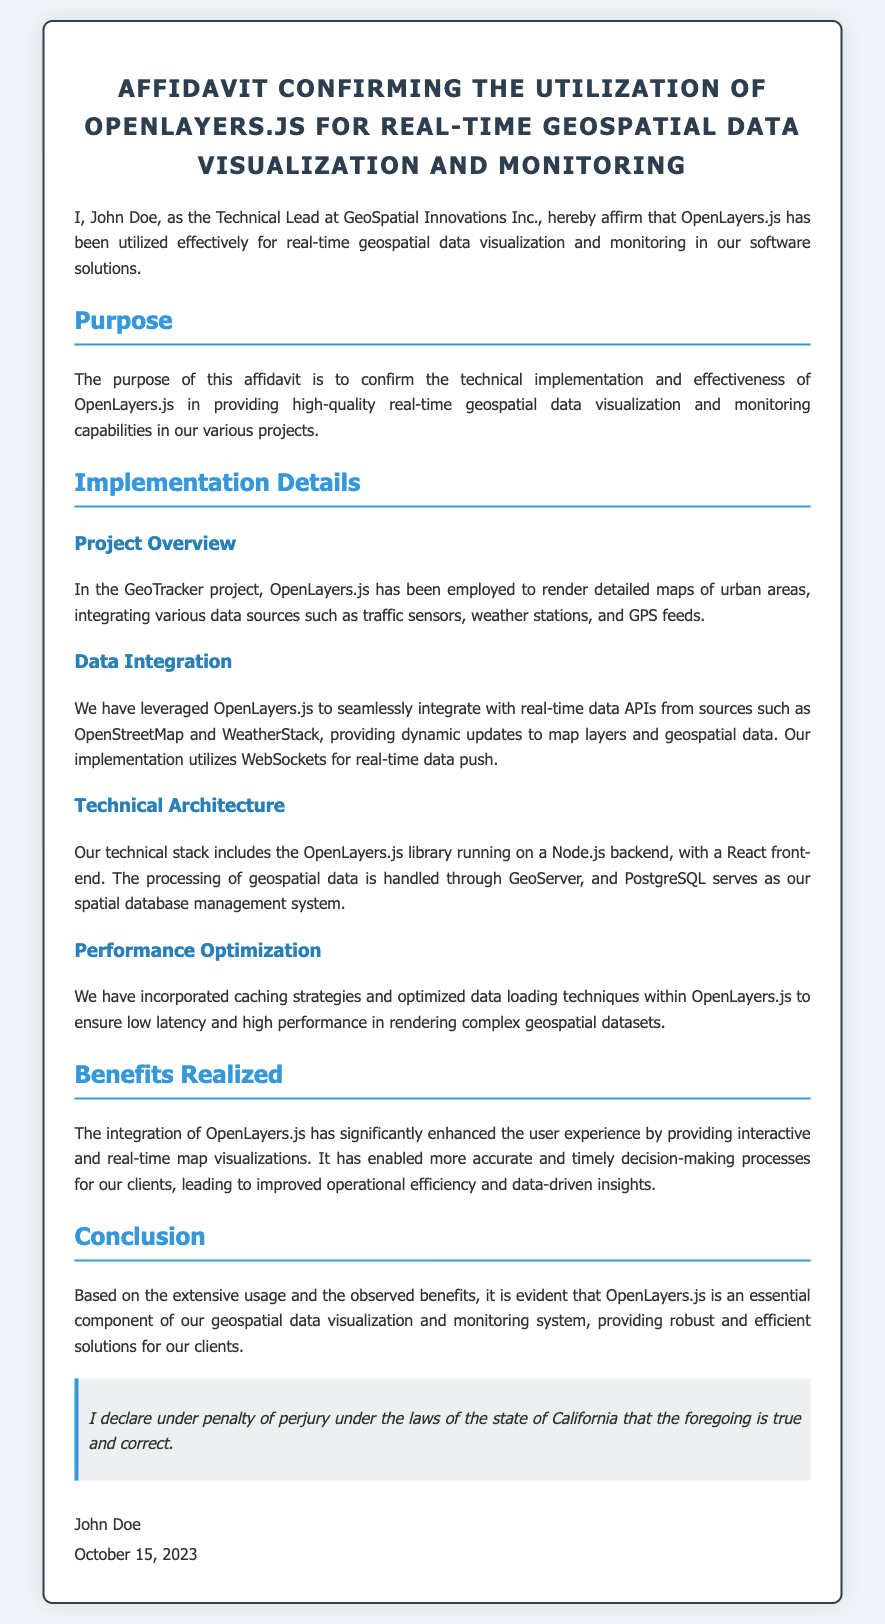What is the name of the Technical Lead? The Technical Lead's name is mentioned at the beginning of the affidavit, confirming their identity and role.
Answer: John Doe What is the date of the affidavit? The date at the end of the affidavit indicates when the declaration was made by the Technical Lead.
Answer: October 15, 2023 What software library is confirmed to be utilized in the affidavit? The affidavit explicitly states which library has been utilized for geospatial data visualization and monitoring.
Answer: OpenLayers.js What backend technology is mentioned in the technical architecture? The technical architecture section highlights the server-side technology used in conjunction with OpenLayers.js.
Answer: Node.js What type of database is used for spatial data management? The affidavit specifies the database technology that manages the geospatial data for their applications.
Answer: PostgreSQL Why is OpenLayers.js considered essential? The conclusion summarizes the perceived significance of the technology to their operations, emphasizing its impact on their services.
Answer: Robust and efficient solutions What is the main benefit realized from using OpenLayers.js? The benefits section describes the primary advantage experienced through the implementation of the OpenLayers.js library.
Answer: Enhanced user experience What type of data sources does OpenLayers.js integrate with? The data integration section identifies the types of data sources used to enhance the mapping capabilities in their project.
Answer: Traffic sensors, weather stations, and GPS feeds What is the purpose of the affidavit? The purpose section outlines the reason for creating this document confirming the technical usage of a specific software library.
Answer: Confirm technical implementation and effectiveness 